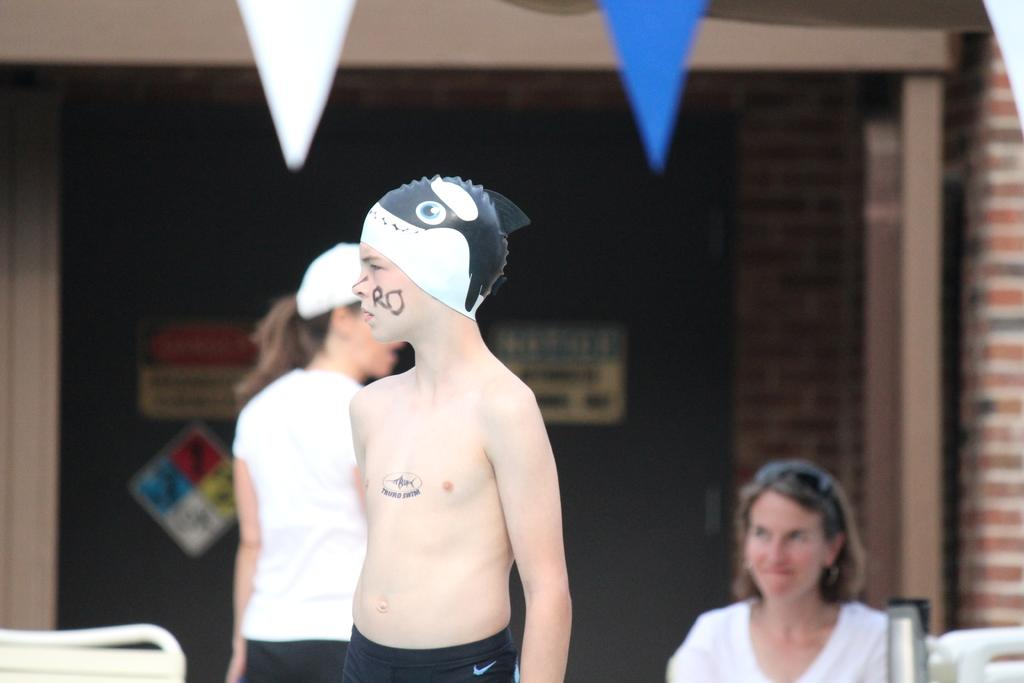Who is the main subject in the image? There is a boy in the image. What is the boy wearing on his head? The boy is wearing a cap. Can you describe the background of the image? There are two people in the background of the image. What is on the wall in the image? There is a wall with posters in the image. What type of grass can be seen growing on the judge's robe in the image? There is no judge or grass present in the image. Are there any cobwebs visible on the wall with posters in the image? There is no mention of cobwebs in the image; only the wall with posters is described. 